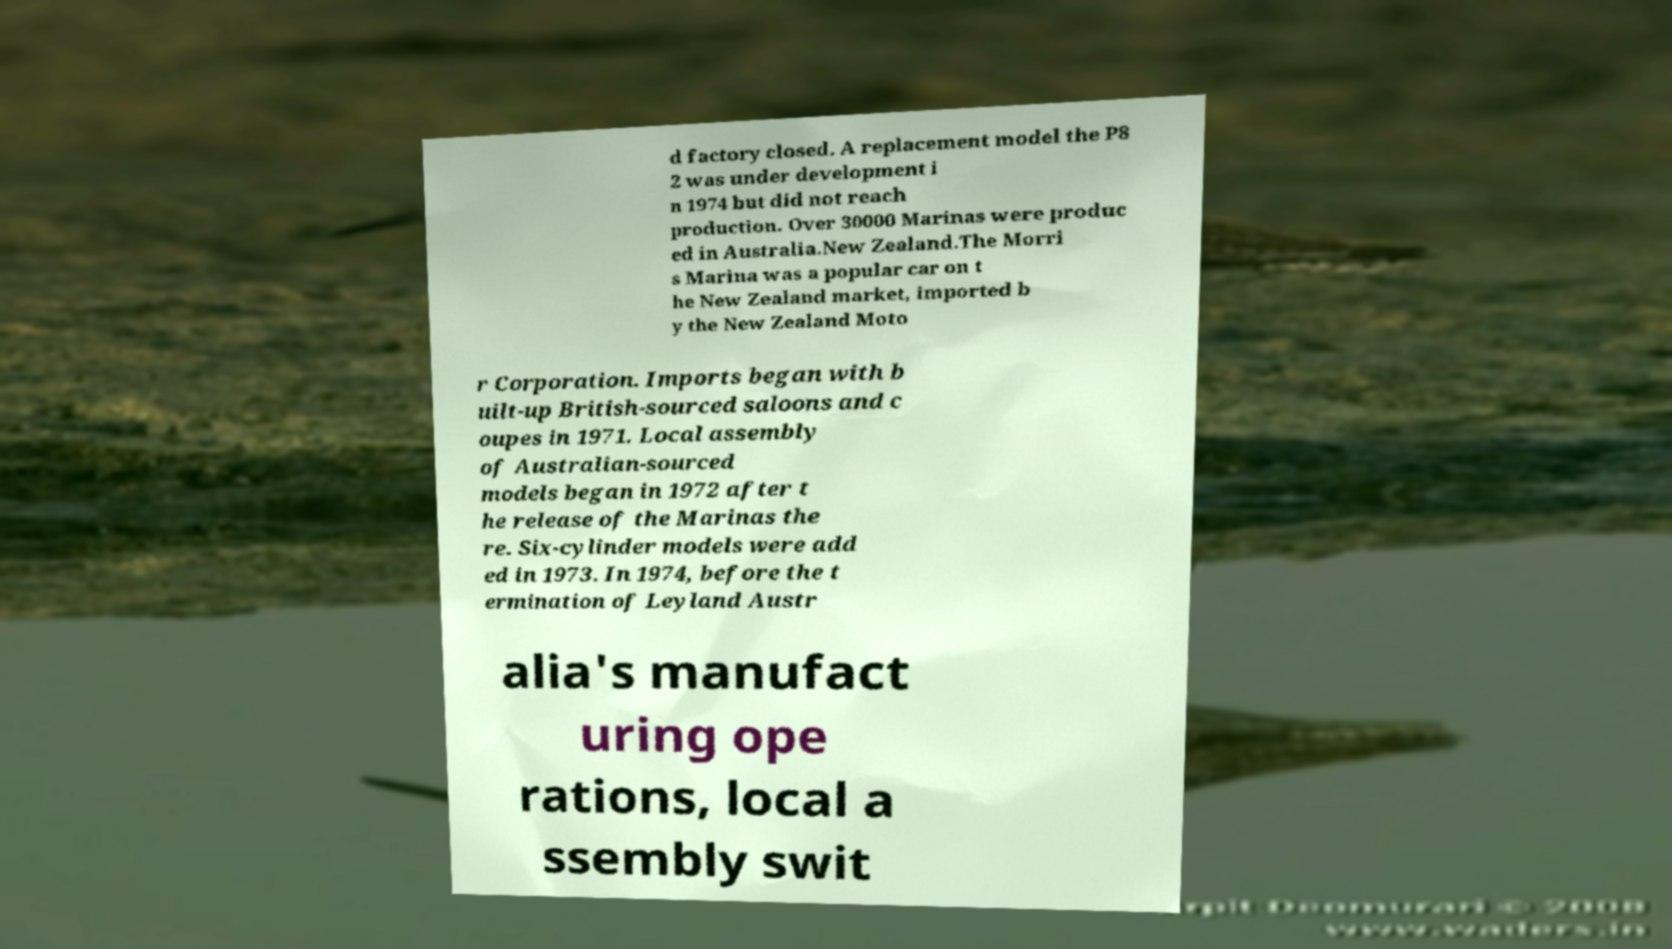Please identify and transcribe the text found in this image. d factory closed. A replacement model the P8 2 was under development i n 1974 but did not reach production. Over 30000 Marinas were produc ed in Australia.New Zealand.The Morri s Marina was a popular car on t he New Zealand market, imported b y the New Zealand Moto r Corporation. Imports began with b uilt-up British-sourced saloons and c oupes in 1971. Local assembly of Australian-sourced models began in 1972 after t he release of the Marinas the re. Six-cylinder models were add ed in 1973. In 1974, before the t ermination of Leyland Austr alia's manufact uring ope rations, local a ssembly swit 